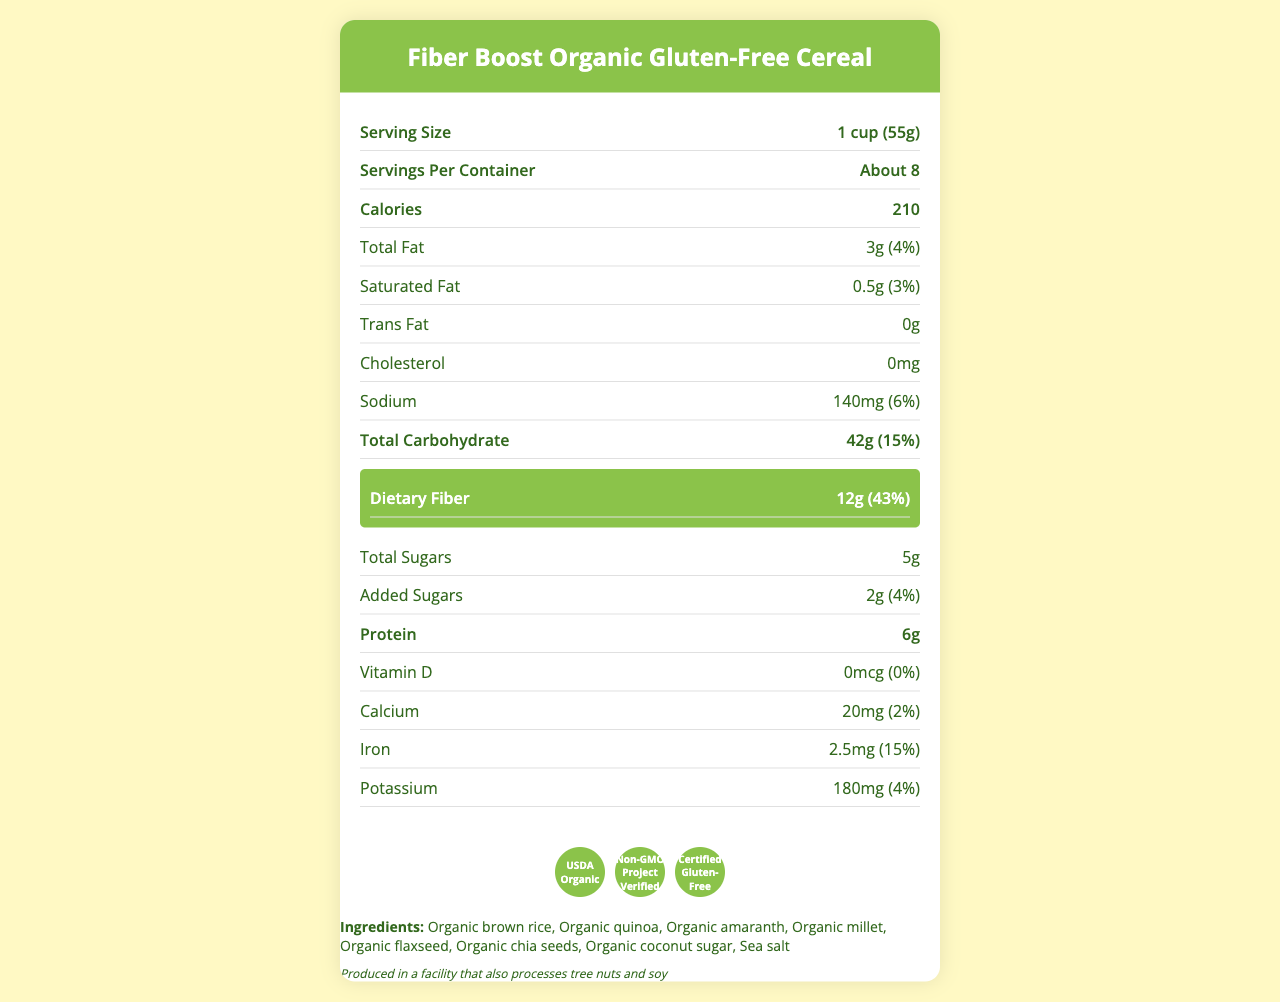How many grams of dietary fiber are in one serving of the cereal? The Nutrition Facts section highlights dietary fiber content and explicitly states it as 12g per serving.
Answer: 12g What is the daily value percentage for dietary fiber in this cereal? The document mentions that the daily value for dietary fiber provided by this cereal is 43%.
Answer: 43% Which ingredient is not organic? The document lists all ingredients prefixed with "organic," indicating that all are organic.
Answer: All listed ingredients are organic What certifications does the cereal have? The certifications section displays these three certifications clearly.
Answer: USDA Organic, Non-GMO Project Verified, Certified Gluten-Free How many grams of protein are in one serving of the cereal? The protein content is listed in the Nutrition Facts section as 6g.
Answer: 6g What is the primary highlight intended for this cereal? A. High Protein B. Low Fat C. High Fiber D. Low Carbohydrate The design highlights dietary fiber, and the nutrition section indicates a high fiber content of 12g (43% daily value).
Answer: C How many servings are in one container? A. About 6 B. About 8 C. About 10 D. About 12 The Nutrition Facts label lists "About 8" servings per container.
Answer: B Is there any cholesterol in this cereal? The Nutrition Facts section lists the cholesterol content as "0mg."
Answer: No Does this cereal contain any added sugars? The label indicates added sugars of 2g (4% daily value).
Answer: Yes What main idea does the document convey? The document presents Fiber Boost as a nutritious, high-fiber, organic, and gluten-free cereal, highlighting its dietary benefits and certifications.
Answer: High-fiber, organic, gluten-free cereal with detailed nutritional information What is the calorie count for a serving of this cereal? The Nutrition Facts section lists the calorie content as 210 per serving.
Answer: 210 calories What is the purpose of the interactive elements in the UI? The UI considerations section lists features like hoverable ingredient lists, expandable certification sections, and clickable dietary fiber highlights to enhance user experience.
Answer: To enhance user interaction by providing additional information and convenience How does this document suggest making it easier to read on mobile devices? The user experience notes recommend an intuitive zoom feature for easier reading on mobile devices.
Answer: By creating a zoom feature What is the sodium content in one serving? The Nutrition Facts section lists the sodium content as 140mg per serving.
Answer: 140mg What is the visual theme of the document? The UI considerations detail a color scheme with primary green (#8BC34A) and secondary yellow (#FFF9C4), using the Open Sans font and a vertical stacked layout for mobile responsiveness.
Answer: Green and yellow with Open Sans font, vertical layout What are the interactive elements mentioned in the document? The UI considerations list these interactive elements to improve user experience.
Answer: Hoverable ingredients list, expandable certifications section, clickable dietary fiber highlight Can this cereal be consumed by people with soy allergies? The document mentions potential cross-contamination in a facility processing tree nuts and soy but not definitive allergen content in the cereal itself.
Answer: Cannot be determined 